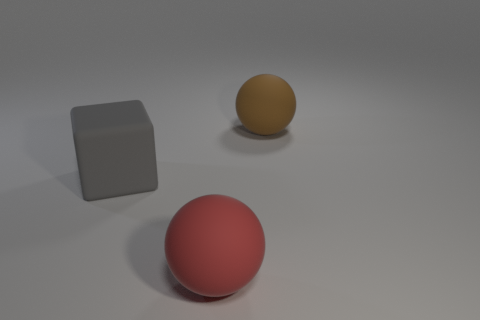Is the number of big purple matte things less than the number of large things?
Provide a succinct answer. Yes. Is there a big rubber sphere that has the same color as the cube?
Provide a succinct answer. No. There is a object that is to the left of the large brown rubber sphere and behind the large red rubber object; what is its shape?
Provide a short and direct response. Cube. What shape is the large matte thing that is in front of the large matte thing on the left side of the red object?
Offer a very short reply. Sphere. Is the large brown rubber thing the same shape as the red rubber object?
Give a very brief answer. Yes. There is a big matte object that is on the left side of the ball in front of the brown ball; how many gray things are behind it?
Offer a very short reply. 0. There is a big brown object that is made of the same material as the large gray object; what is its shape?
Provide a short and direct response. Sphere. What is the material of the large ball that is left of the large matte sphere on the right side of the big rubber object in front of the large gray matte thing?
Keep it short and to the point. Rubber. How many things are large balls that are in front of the gray object or gray blocks?
Keep it short and to the point. 2. What number of other objects are there of the same shape as the brown matte object?
Provide a succinct answer. 1. 